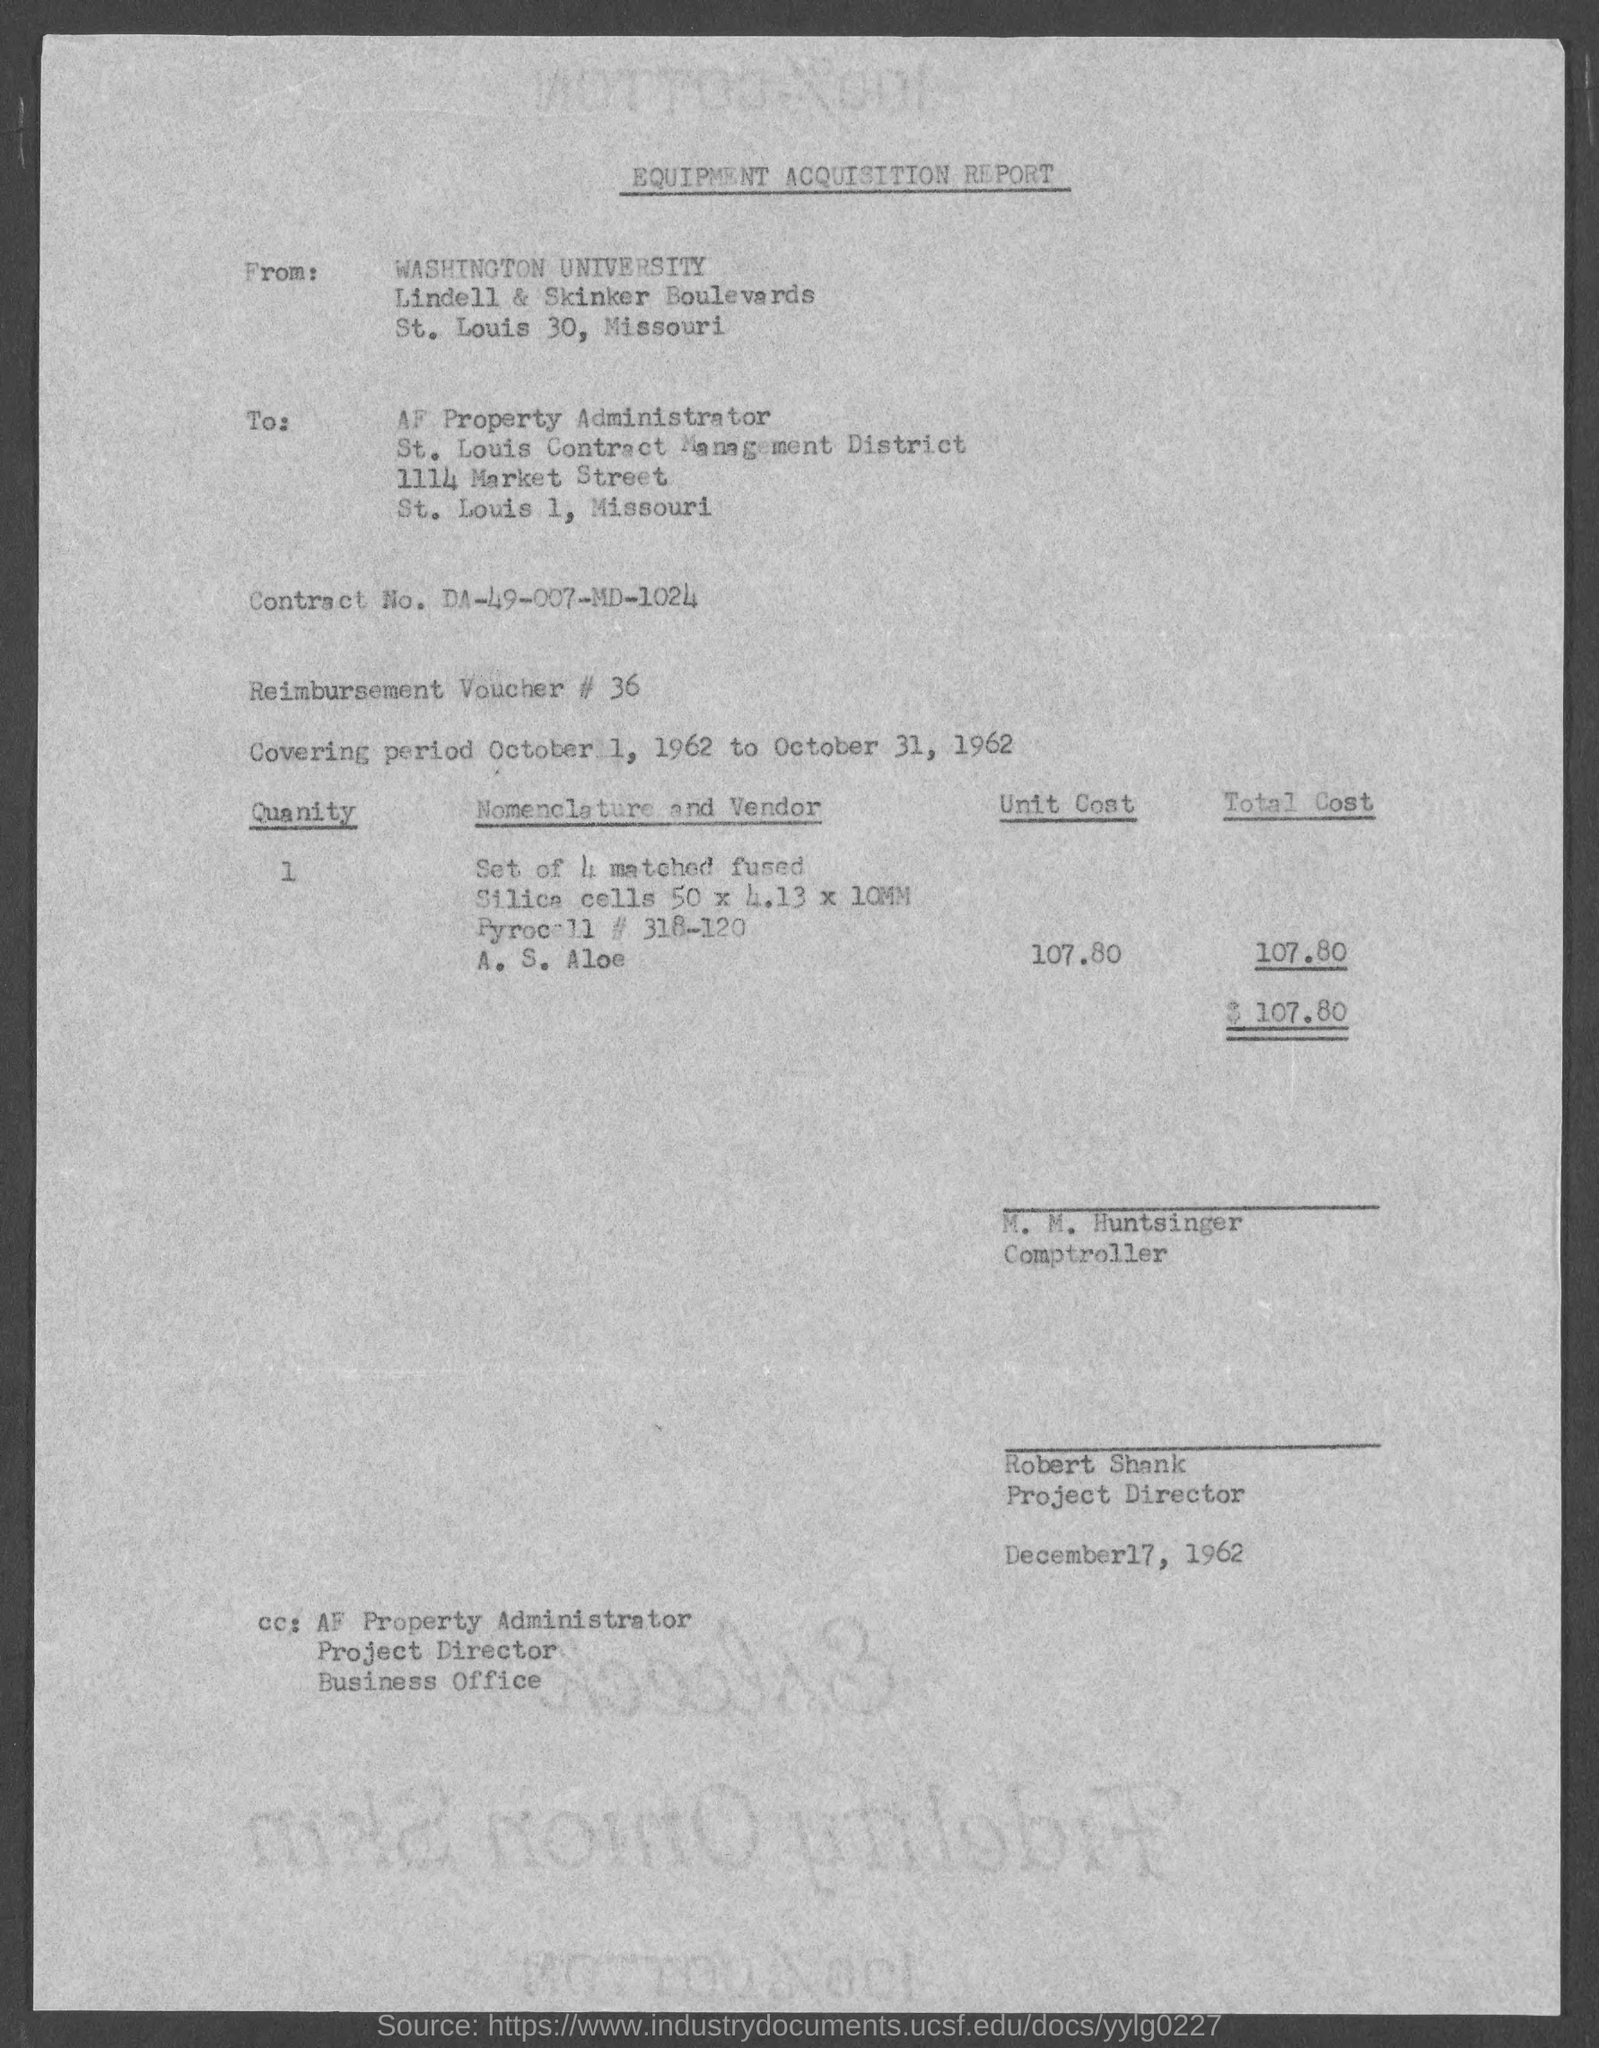Indicate a few pertinent items in this graphic. This is an equipment acquisition report. The date mentioned in the equipment acquisition report is December 17, 1962. In the report, the reimbursement voucher number is 36. The covering period mentioned in the report is from October 1, 1962 to October 31, 1962. The Contract No. mentioned in the report is DA-49-007-MD-1024. 